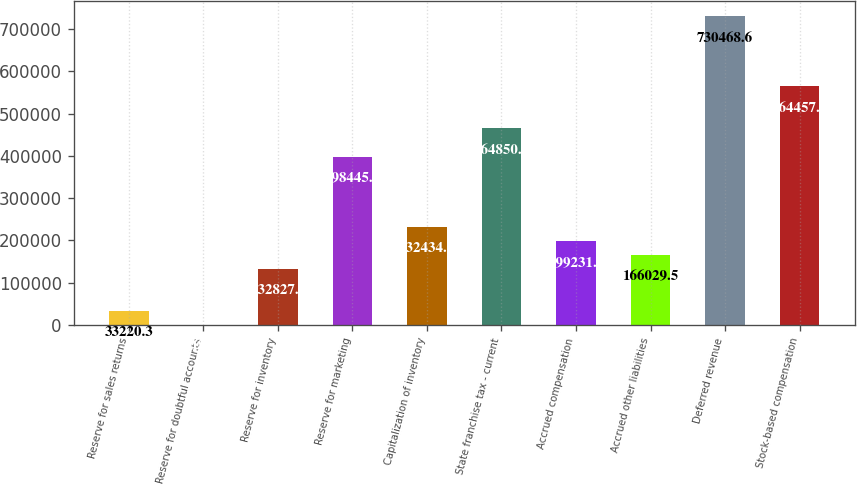Convert chart. <chart><loc_0><loc_0><loc_500><loc_500><bar_chart><fcel>Reserve for sales returns<fcel>Reserve for doubtful accounts<fcel>Reserve for inventory<fcel>Reserve for marketing<fcel>Capitalization of inventory<fcel>State franchise tax - current<fcel>Accrued compensation<fcel>Accrued other liabilities<fcel>Deferred revenue<fcel>Stock-based compensation<nl><fcel>33220.3<fcel>18<fcel>132827<fcel>398446<fcel>232434<fcel>464850<fcel>199232<fcel>166030<fcel>730469<fcel>564457<nl></chart> 